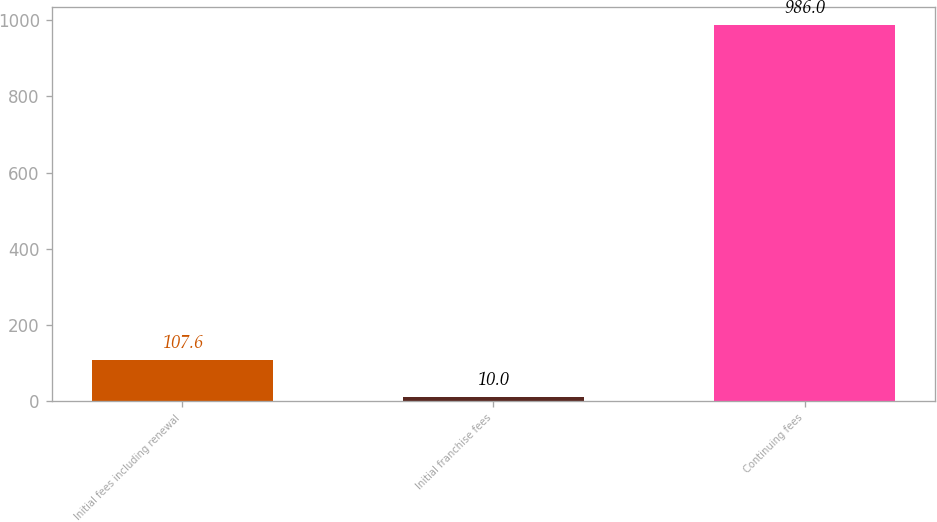<chart> <loc_0><loc_0><loc_500><loc_500><bar_chart><fcel>Initial fees including renewal<fcel>Initial franchise fees<fcel>Continuing fees<nl><fcel>107.6<fcel>10<fcel>986<nl></chart> 